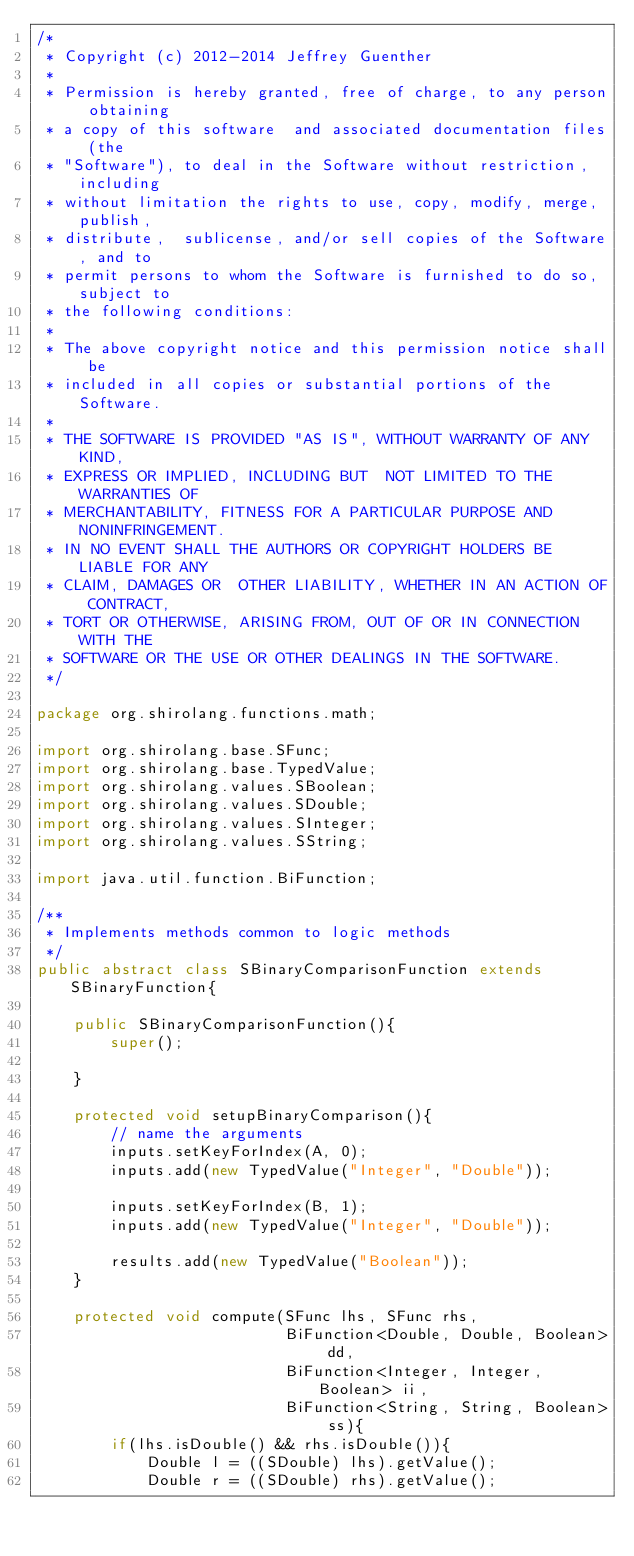<code> <loc_0><loc_0><loc_500><loc_500><_Java_>/*
 * Copyright (c) 2012-2014 Jeffrey Guenther
 *
 * Permission is hereby granted, free of charge, to any person obtaining
 * a copy of this software  and associated documentation files (the
 * "Software"), to deal in the Software without restriction,  including
 * without limitation the rights to use, copy, modify, merge, publish,
 * distribute,  sublicense, and/or sell copies of the Software, and to
 * permit persons to whom the Software is furnished to do so, subject to
 * the following conditions:
 *
 * The above copyright notice and this permission notice shall be
 * included in all copies or substantial portions of the Software.
 *
 * THE SOFTWARE IS PROVIDED "AS IS", WITHOUT WARRANTY OF ANY KIND,
 * EXPRESS OR IMPLIED, INCLUDING BUT  NOT LIMITED TO THE WARRANTIES OF
 * MERCHANTABILITY, FITNESS FOR A PARTICULAR PURPOSE AND NONINFRINGEMENT.
 * IN NO EVENT SHALL THE AUTHORS OR COPYRIGHT HOLDERS BE LIABLE FOR ANY
 * CLAIM, DAMAGES OR  OTHER LIABILITY, WHETHER IN AN ACTION OF CONTRACT,
 * TORT OR OTHERWISE, ARISING FROM, OUT OF OR IN CONNECTION WITH THE
 * SOFTWARE OR THE USE OR OTHER DEALINGS IN THE SOFTWARE.
 */

package org.shirolang.functions.math;

import org.shirolang.base.SFunc;
import org.shirolang.base.TypedValue;
import org.shirolang.values.SBoolean;
import org.shirolang.values.SDouble;
import org.shirolang.values.SInteger;
import org.shirolang.values.SString;

import java.util.function.BiFunction;

/**
 * Implements methods common to logic methods
 */
public abstract class SBinaryComparisonFunction extends SBinaryFunction{

    public SBinaryComparisonFunction(){
        super();

    }

    protected void setupBinaryComparison(){
        // name the arguments
        inputs.setKeyForIndex(A, 0);
        inputs.add(new TypedValue("Integer", "Double"));

        inputs.setKeyForIndex(B, 1);
        inputs.add(new TypedValue("Integer", "Double"));

        results.add(new TypedValue("Boolean"));
    }

    protected void compute(SFunc lhs, SFunc rhs,
                           BiFunction<Double, Double, Boolean> dd,
                           BiFunction<Integer, Integer, Boolean> ii,
                           BiFunction<String, String, Boolean> ss){
        if(lhs.isDouble() && rhs.isDouble()){
            Double l = ((SDouble) lhs).getValue();
            Double r = ((SDouble) rhs).getValue();</code> 